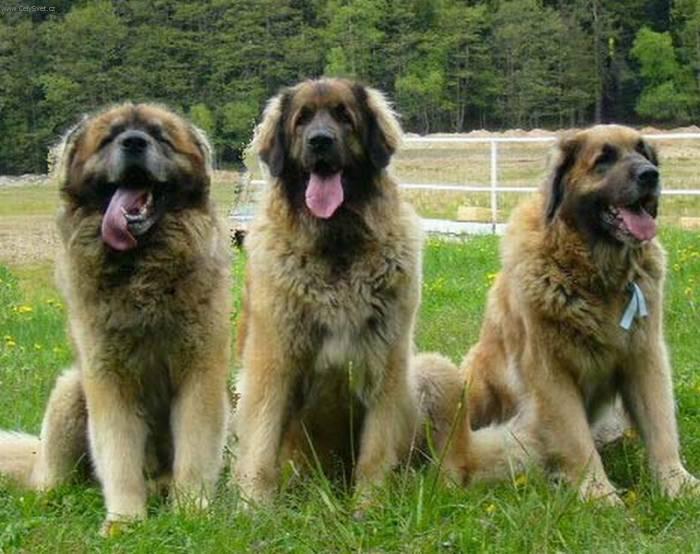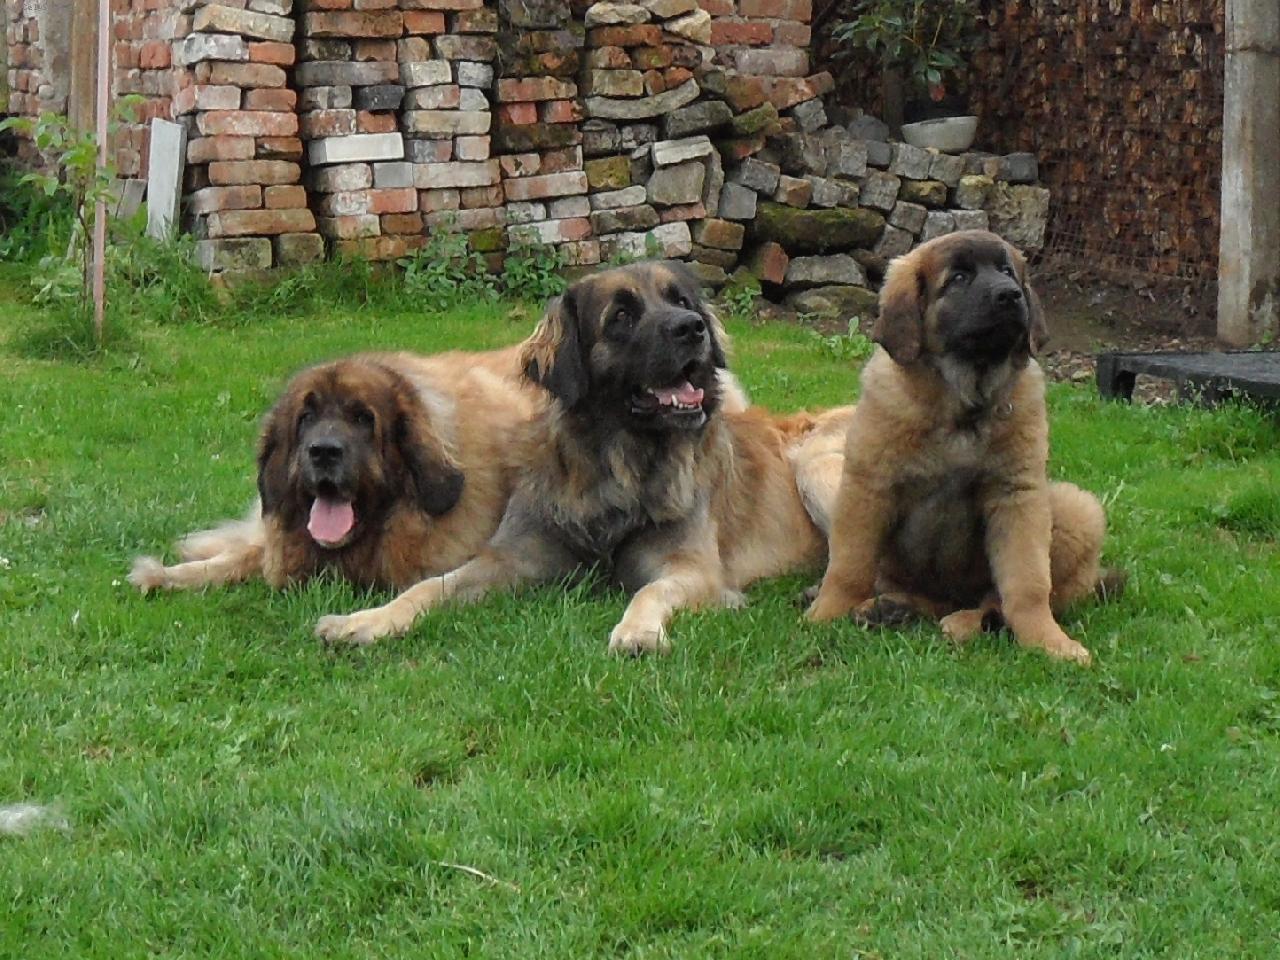The first image is the image on the left, the second image is the image on the right. Analyze the images presented: Is the assertion "There are no more than three dogs" valid? Answer yes or no. No. The first image is the image on the left, the second image is the image on the right. Considering the images on both sides, is "Right and left images contain the same number of dogs." valid? Answer yes or no. Yes. 